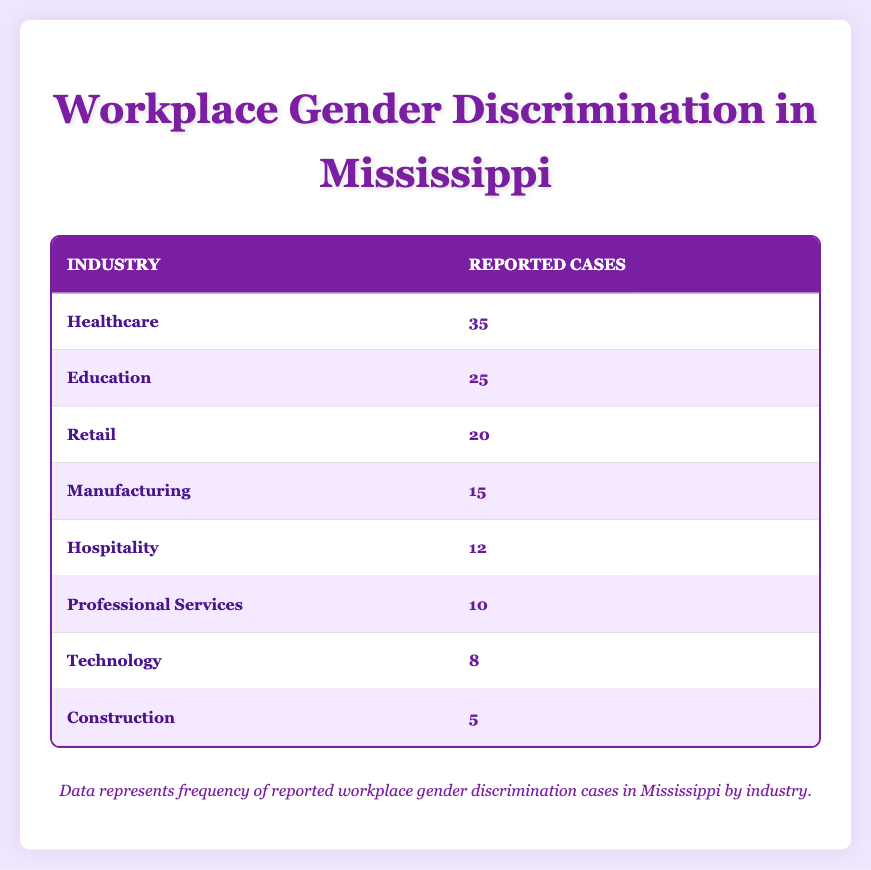What industry has the highest reported cases of gender discrimination? The table shows that the industry with the highest number of reported cases is Healthcare, with 35 cases reported.
Answer: Healthcare How many cases were reported in the Education industry? The table indicates that there were 25 reported cases in the Education industry.
Answer: 25 Which industry reported less than 10 cases of gender discrimination? By examining the table, Technology had 8 reported cases, which is less than 10.
Answer: Technology What is the total number of reported cases across all industries? To find the total, add the reported cases: 35 (Healthcare) + 25 (Education) + 20 (Retail) + 15 (Manufacturing) + 12 (Hospitality) + 10 (Professional Services) + 8 (Technology) + 5 (Construction) = 130.
Answer: 130 Is there a higher number of cases reported in Professional Services compared to Hospitality? The table shows that Professional Services had 10 cases reported while Hospitality had 12, indicating that the statement is false.
Answer: No What is the difference in the number of reported cases between the Healthcare and Construction industries? Healthcare reported 35 cases while Construction had 5. To find the difference, subtract 5 from 35: 35 - 5 = 30.
Answer: 30 Which two industries combined had more reported cases than the Retail industry? Retail reported 20 cases. Analyzing the table, Healthcare (35) and Education (25) both exceed 20 when combined (35 + 25 = 60), confirming they have more.
Answer: Healthcare and Education What percentage of reported cases come from the Hospitality industry compared to the total? The Hospitality industry reported 12 cases. Taking the total number of cases (130), the percentage is calculated as (12/130) * 100 ≈ 9.23%.
Answer: 9.23% What is the median number of reported cases across all industries listed? To find the median, list all case numbers in ascending order: 5, 8, 10, 12, 15, 20, 25, 35 (8 values). The median is the average of the 4th and 5th values: (12 + 15) / 2 = 13.5.
Answer: 13.5 